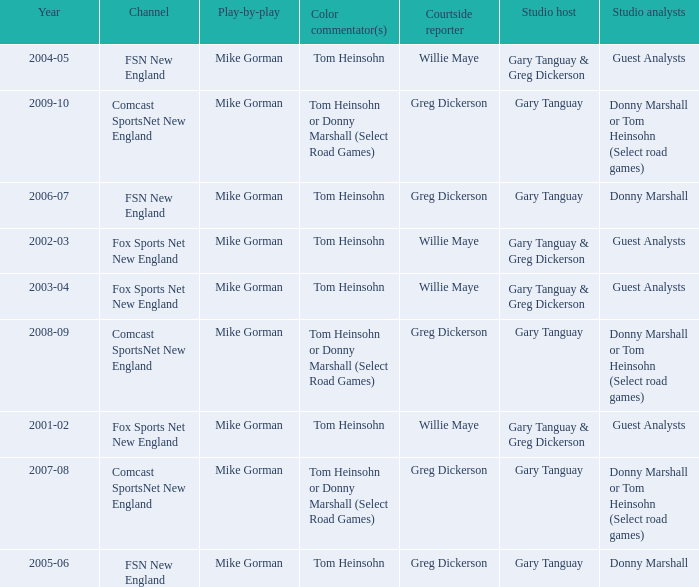Who are the studio analysts for the year 2008-09? Donny Marshall or Tom Heinsohn (Select road games). 